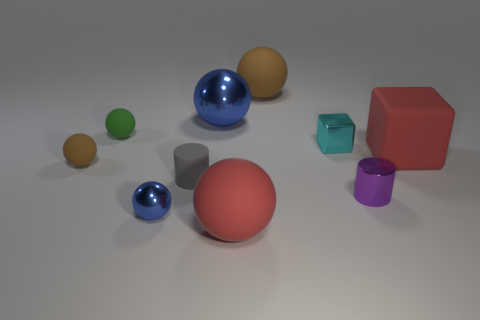Are there any other tiny cylinders that have the same material as the small purple cylinder?
Provide a succinct answer. No. There is a blue metal object behind the purple thing; is it the same size as the small cyan cube?
Offer a very short reply. No. How many cyan things are either small metallic cylinders or tiny metallic cubes?
Offer a terse response. 1. What is the brown thing to the right of the big metal sphere made of?
Your answer should be compact. Rubber. What number of blue objects are behind the shiny sphere in front of the tiny rubber cylinder?
Give a very brief answer. 1. What number of other rubber things have the same shape as the tiny green matte object?
Give a very brief answer. 3. What number of gray balls are there?
Offer a very short reply. 0. There is a rubber cube that is behind the tiny gray object; what color is it?
Give a very brief answer. Red. There is a shiny sphere that is in front of the brown rubber ball that is in front of the large brown sphere; what is its color?
Provide a short and direct response. Blue. What color is the metal ball that is the same size as the gray cylinder?
Your answer should be very brief. Blue. 